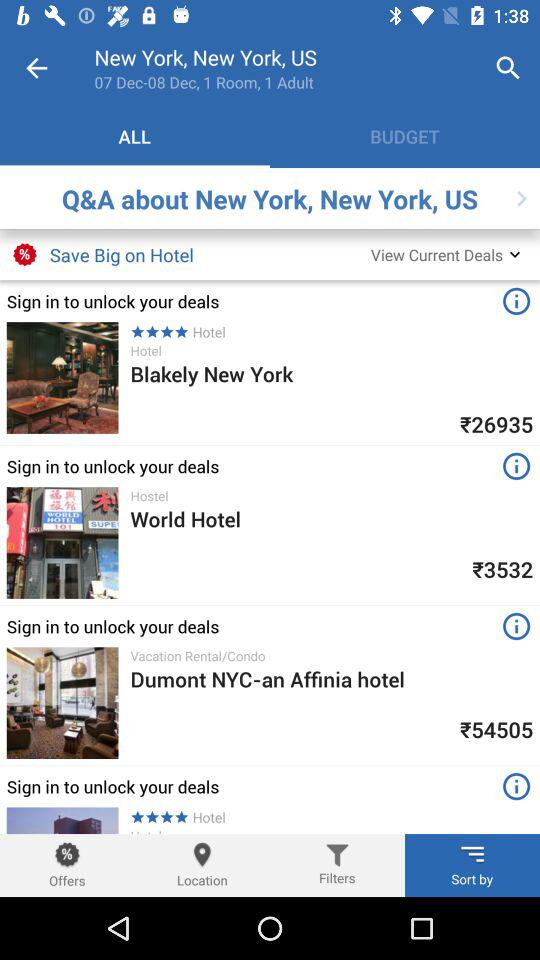What is the rating of "Blakely New York"? The rating is 4 stars. 